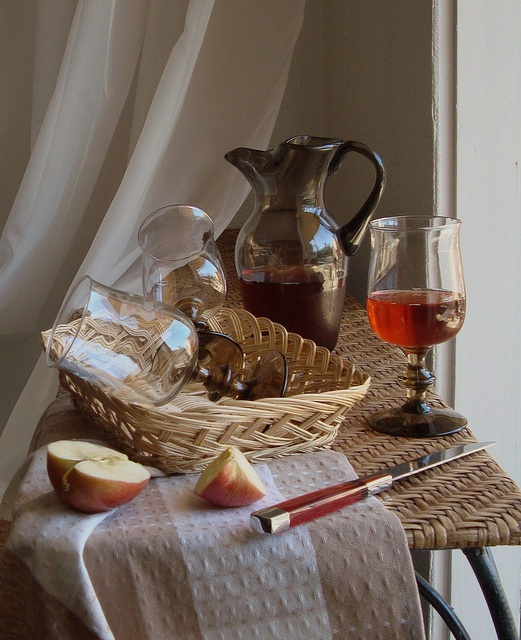Describe the objects in this image and their specific colors. I can see dining table in gray, darkgray, maroon, and black tones, vase in gray, black, and maroon tones, bowl in gray, maroon, and tan tones, wine glass in gray, maroon, and black tones, and wine glass in gray and darkgray tones in this image. 